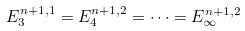<formula> <loc_0><loc_0><loc_500><loc_500>E _ { 3 } ^ { n + 1 , 1 } = E _ { 4 } ^ { n + 1 , 2 } = \dots = E _ { \infty } ^ { n + 1 , 2 }</formula> 